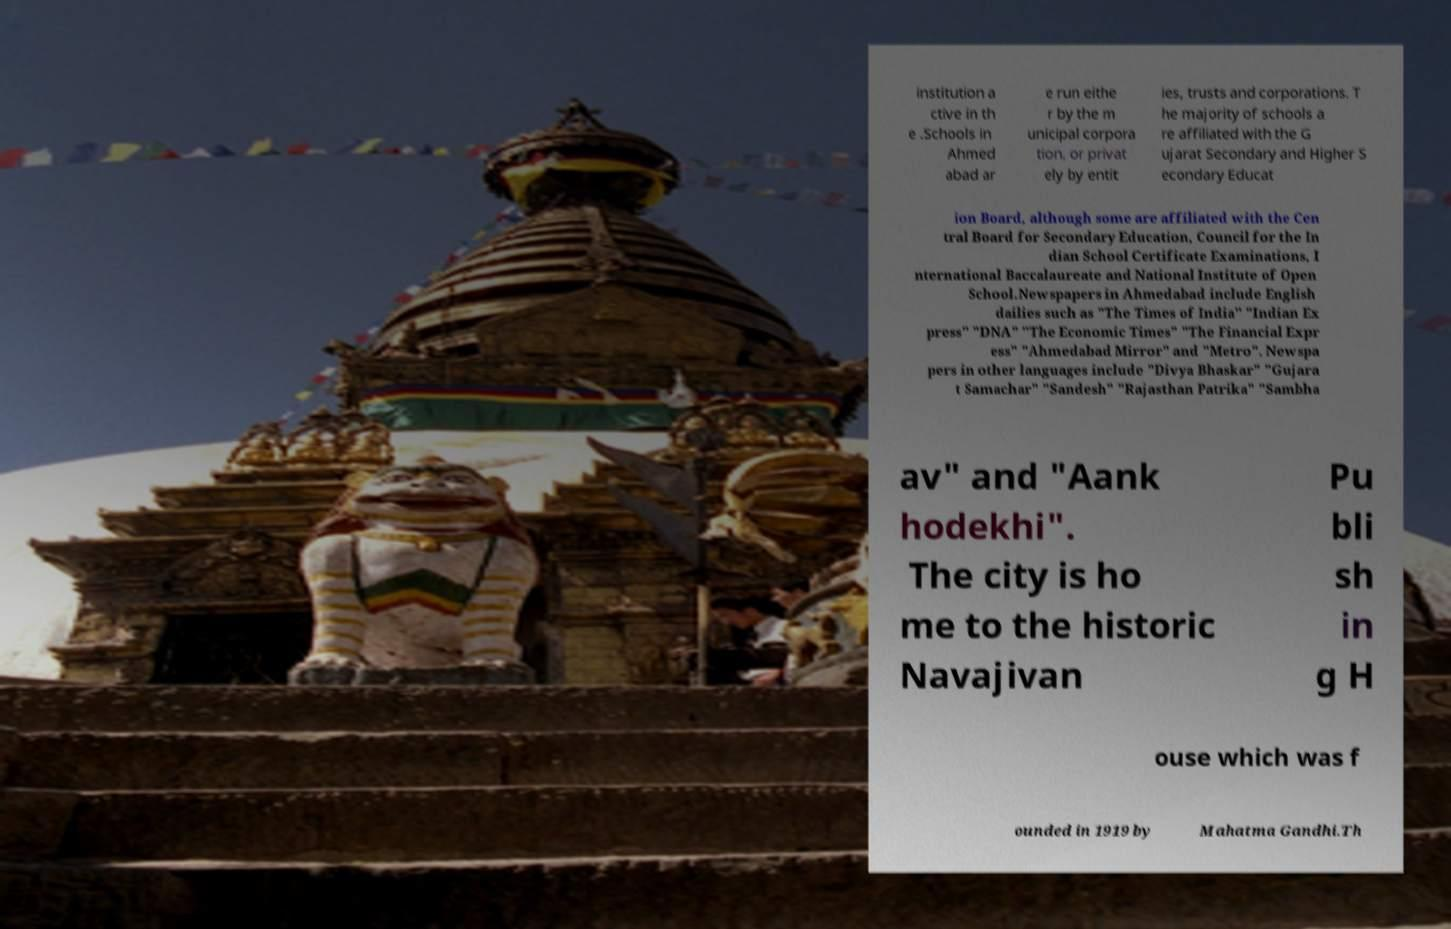Can you accurately transcribe the text from the provided image for me? institution a ctive in th e .Schools in Ahmed abad ar e run eithe r by the m unicipal corpora tion, or privat ely by entit ies, trusts and corporations. T he majority of schools a re affiliated with the G ujarat Secondary and Higher S econdary Educat ion Board, although some are affiliated with the Cen tral Board for Secondary Education, Council for the In dian School Certificate Examinations, I nternational Baccalaureate and National Institute of Open School.Newspapers in Ahmedabad include English dailies such as "The Times of India" "Indian Ex press" "DNA" "The Economic Times" "The Financial Expr ess" "Ahmedabad Mirror" and "Metro". Newspa pers in other languages include "Divya Bhaskar" "Gujara t Samachar" "Sandesh" "Rajasthan Patrika" "Sambha av" and "Aank hodekhi". The city is ho me to the historic Navajivan Pu bli sh in g H ouse which was f ounded in 1919 by Mahatma Gandhi.Th 